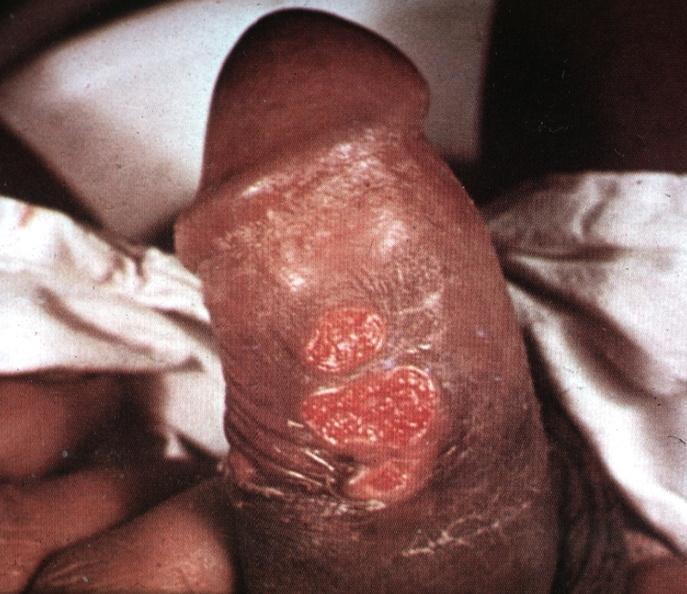s node metastases labeled chancroid?
Answer the question using a single word or phrase. No 